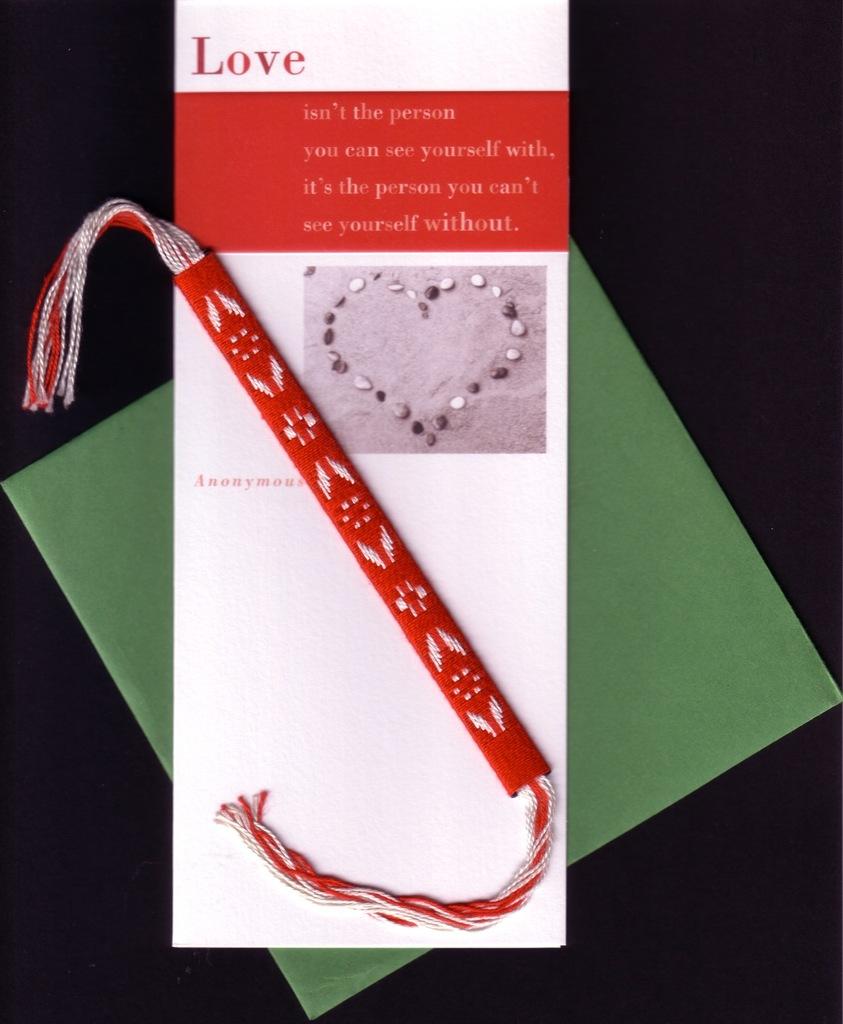Which common emotion is printed on the top of the brochure?
Offer a terse response. Love. What is the color of the word love?
Your answer should be very brief. Red. 